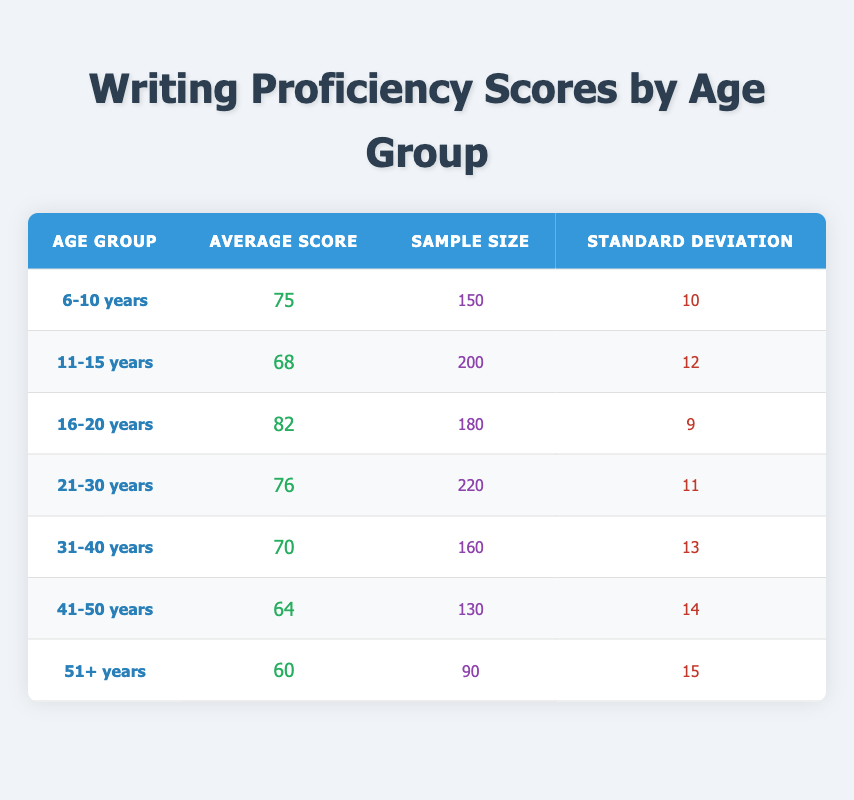What is the average score for the age group 16-20 years? The table shows that the average score for the age group 16-20 years is explicitly listed in the "Average Score" column. Thus, we can find the value directly from that column.
Answer: 82 How many learners were included in the age group 41-50 years? The sample size for the age group 41-50 years is provided in the "Sample Size" column of that specific row in the table. According to the table, there were 130 learners in this age group.
Answer: 130 Is the average writing proficiency score for the age group 31-40 years greater than 75? The average score for the age group 31-40 years is written in the table as 70. Since 70 is less than 75, the answer to this question is no.
Answer: No What is the difference in average writing scores between the age groups 6-10 and 51+ years? The table provides the average score for the age group 6-10 years as 75 and for the age group 51+ years as 60. To find the difference, we subtract 60 from 75. Therefore, 75 - 60 = 15.
Answer: 15 Which age group has the highest average writing proficiency score? By examining the "Average Score" column for all age groups, we find that the age group 16-20 years has the highest score of 82. All other groups have lower scores.
Answer: 16-20 years What is the average score of the age groups 11-15 years and 21-30 years combined? The average score for 11-15 years is 68 and for 21-30 years is 76. To find the average of these two scores, we add them together and divide by 2. The calculation is (68 + 76) / 2 = 144 / 2 = 72.
Answer: 72 How does the standard deviation of the 51+ years age group compare to that of the 6-10 years age group? The standard deviation for the 51+ years group is given as 15, while the standard deviation for the 6-10 years group is 10. Since 15 is greater than 10, we conclude that the 51+ years group has a higher standard deviation.
Answer: 51+ years group has a higher standard deviation 